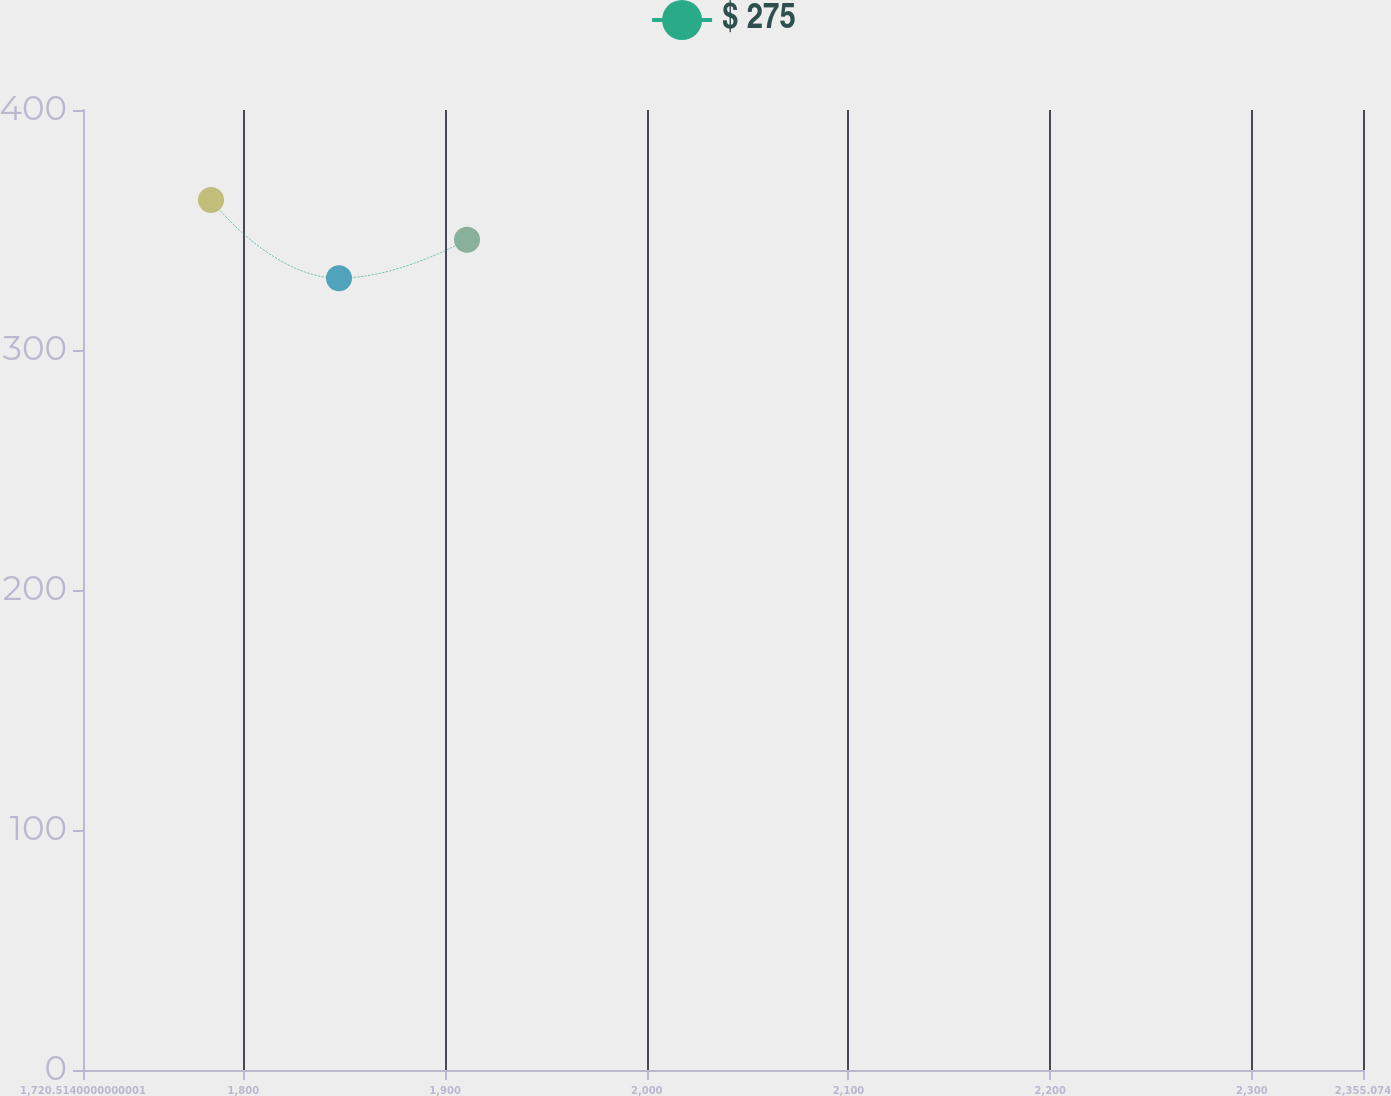Convert chart to OTSL. <chart><loc_0><loc_0><loc_500><loc_500><line_chart><ecel><fcel>$ 275<nl><fcel>1783.97<fcel>362.51<nl><fcel>1847.43<fcel>329.92<nl><fcel>1910.89<fcel>345.96<nl><fcel>2418.53<fcel>418.65<nl></chart> 